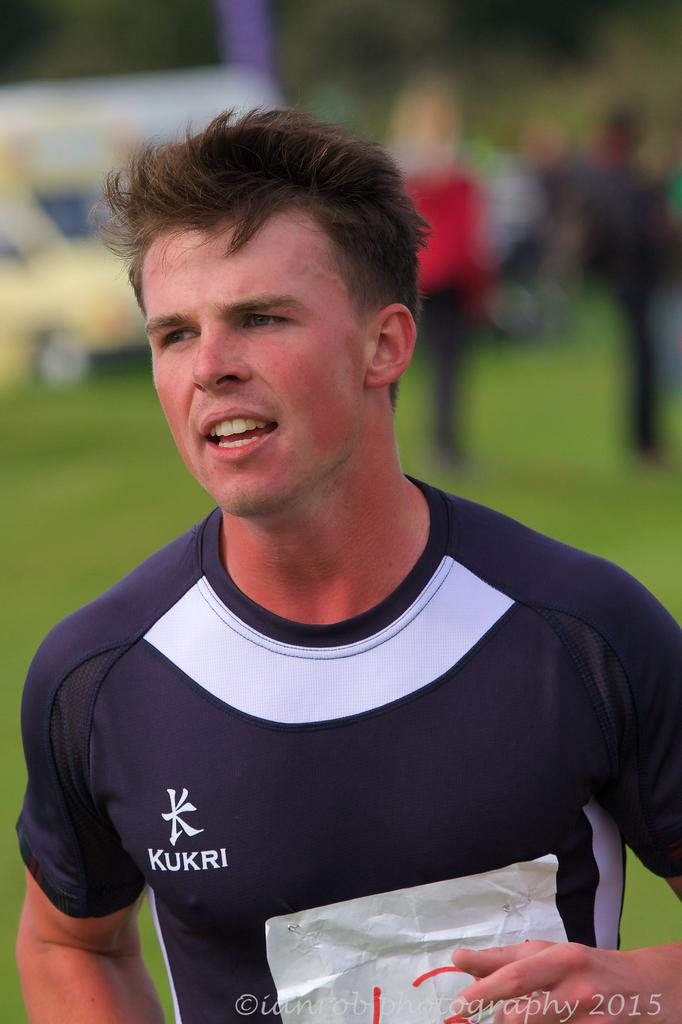<image>
Share a concise interpretation of the image provided. a an wearing a KUKRI shirt outside & copyrighted ianrobphotography 2015 